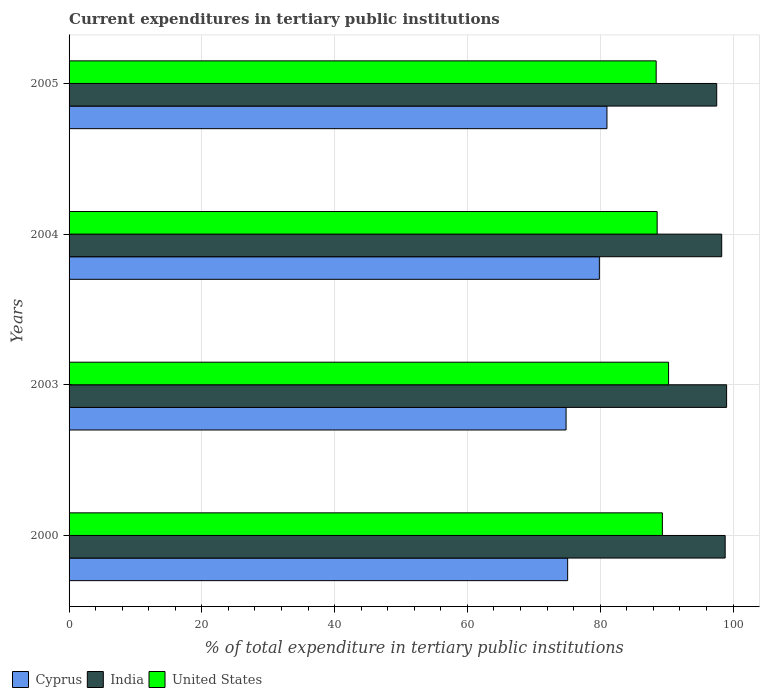How many different coloured bars are there?
Your answer should be very brief. 3. How many groups of bars are there?
Your answer should be very brief. 4. Are the number of bars on each tick of the Y-axis equal?
Offer a very short reply. Yes. How many bars are there on the 2nd tick from the top?
Make the answer very short. 3. What is the current expenditures in tertiary public institutions in Cyprus in 2005?
Keep it short and to the point. 81.01. Across all years, what is the maximum current expenditures in tertiary public institutions in Cyprus?
Provide a short and direct response. 81.01. Across all years, what is the minimum current expenditures in tertiary public institutions in United States?
Offer a terse response. 88.43. In which year was the current expenditures in tertiary public institutions in India maximum?
Offer a very short reply. 2003. What is the total current expenditures in tertiary public institutions in Cyprus in the graph?
Provide a short and direct response. 310.84. What is the difference between the current expenditures in tertiary public institutions in United States in 2000 and that in 2004?
Give a very brief answer. 0.79. What is the difference between the current expenditures in tertiary public institutions in Cyprus in 2005 and the current expenditures in tertiary public institutions in India in 2000?
Your answer should be very brief. -17.81. What is the average current expenditures in tertiary public institutions in India per year?
Your response must be concise. 98.42. In the year 2005, what is the difference between the current expenditures in tertiary public institutions in India and current expenditures in tertiary public institutions in United States?
Your answer should be very brief. 9.12. In how many years, is the current expenditures in tertiary public institutions in India greater than 76 %?
Provide a short and direct response. 4. What is the ratio of the current expenditures in tertiary public institutions in Cyprus in 2000 to that in 2005?
Keep it short and to the point. 0.93. What is the difference between the highest and the second highest current expenditures in tertiary public institutions in India?
Your response must be concise. 0.22. What is the difference between the highest and the lowest current expenditures in tertiary public institutions in India?
Ensure brevity in your answer.  1.49. In how many years, is the current expenditures in tertiary public institutions in Cyprus greater than the average current expenditures in tertiary public institutions in Cyprus taken over all years?
Provide a short and direct response. 2. Is the sum of the current expenditures in tertiary public institutions in United States in 2003 and 2004 greater than the maximum current expenditures in tertiary public institutions in India across all years?
Your response must be concise. Yes. How many bars are there?
Offer a very short reply. 12. Are all the bars in the graph horizontal?
Provide a succinct answer. Yes. What is the difference between two consecutive major ticks on the X-axis?
Offer a terse response. 20. Are the values on the major ticks of X-axis written in scientific E-notation?
Your response must be concise. No. Where does the legend appear in the graph?
Your response must be concise. Bottom left. How are the legend labels stacked?
Ensure brevity in your answer.  Horizontal. What is the title of the graph?
Your answer should be very brief. Current expenditures in tertiary public institutions. What is the label or title of the X-axis?
Provide a succinct answer. % of total expenditure in tertiary public institutions. What is the label or title of the Y-axis?
Give a very brief answer. Years. What is the % of total expenditure in tertiary public institutions of Cyprus in 2000?
Your response must be concise. 75.1. What is the % of total expenditure in tertiary public institutions of India in 2000?
Provide a succinct answer. 98.82. What is the % of total expenditure in tertiary public institutions in United States in 2000?
Offer a terse response. 89.36. What is the % of total expenditure in tertiary public institutions of Cyprus in 2003?
Your response must be concise. 74.86. What is the % of total expenditure in tertiary public institutions of India in 2003?
Provide a succinct answer. 99.04. What is the % of total expenditure in tertiary public institutions of United States in 2003?
Provide a short and direct response. 90.3. What is the % of total expenditure in tertiary public institutions of Cyprus in 2004?
Offer a terse response. 79.87. What is the % of total expenditure in tertiary public institutions in India in 2004?
Your answer should be very brief. 98.3. What is the % of total expenditure in tertiary public institutions of United States in 2004?
Offer a very short reply. 88.57. What is the % of total expenditure in tertiary public institutions in Cyprus in 2005?
Give a very brief answer. 81.01. What is the % of total expenditure in tertiary public institutions of India in 2005?
Provide a succinct answer. 97.55. What is the % of total expenditure in tertiary public institutions of United States in 2005?
Provide a short and direct response. 88.43. Across all years, what is the maximum % of total expenditure in tertiary public institutions of Cyprus?
Offer a terse response. 81.01. Across all years, what is the maximum % of total expenditure in tertiary public institutions in India?
Make the answer very short. 99.04. Across all years, what is the maximum % of total expenditure in tertiary public institutions of United States?
Keep it short and to the point. 90.3. Across all years, what is the minimum % of total expenditure in tertiary public institutions in Cyprus?
Offer a very short reply. 74.86. Across all years, what is the minimum % of total expenditure in tertiary public institutions of India?
Your answer should be compact. 97.55. Across all years, what is the minimum % of total expenditure in tertiary public institutions in United States?
Your answer should be very brief. 88.43. What is the total % of total expenditure in tertiary public institutions of Cyprus in the graph?
Give a very brief answer. 310.84. What is the total % of total expenditure in tertiary public institutions in India in the graph?
Provide a succinct answer. 393.7. What is the total % of total expenditure in tertiary public institutions of United States in the graph?
Keep it short and to the point. 356.66. What is the difference between the % of total expenditure in tertiary public institutions of Cyprus in 2000 and that in 2003?
Provide a short and direct response. 0.24. What is the difference between the % of total expenditure in tertiary public institutions in India in 2000 and that in 2003?
Your response must be concise. -0.22. What is the difference between the % of total expenditure in tertiary public institutions of United States in 2000 and that in 2003?
Give a very brief answer. -0.94. What is the difference between the % of total expenditure in tertiary public institutions of Cyprus in 2000 and that in 2004?
Your response must be concise. -4.78. What is the difference between the % of total expenditure in tertiary public institutions in India in 2000 and that in 2004?
Your answer should be compact. 0.52. What is the difference between the % of total expenditure in tertiary public institutions of United States in 2000 and that in 2004?
Give a very brief answer. 0.79. What is the difference between the % of total expenditure in tertiary public institutions in Cyprus in 2000 and that in 2005?
Your response must be concise. -5.92. What is the difference between the % of total expenditure in tertiary public institutions in India in 2000 and that in 2005?
Offer a very short reply. 1.27. What is the difference between the % of total expenditure in tertiary public institutions in United States in 2000 and that in 2005?
Offer a very short reply. 0.93. What is the difference between the % of total expenditure in tertiary public institutions of Cyprus in 2003 and that in 2004?
Offer a very short reply. -5.01. What is the difference between the % of total expenditure in tertiary public institutions of India in 2003 and that in 2004?
Keep it short and to the point. 0.74. What is the difference between the % of total expenditure in tertiary public institutions in United States in 2003 and that in 2004?
Keep it short and to the point. 1.72. What is the difference between the % of total expenditure in tertiary public institutions in Cyprus in 2003 and that in 2005?
Give a very brief answer. -6.16. What is the difference between the % of total expenditure in tertiary public institutions in India in 2003 and that in 2005?
Give a very brief answer. 1.49. What is the difference between the % of total expenditure in tertiary public institutions in United States in 2003 and that in 2005?
Make the answer very short. 1.87. What is the difference between the % of total expenditure in tertiary public institutions of Cyprus in 2004 and that in 2005?
Your answer should be very brief. -1.14. What is the difference between the % of total expenditure in tertiary public institutions of India in 2004 and that in 2005?
Your answer should be compact. 0.75. What is the difference between the % of total expenditure in tertiary public institutions in United States in 2004 and that in 2005?
Give a very brief answer. 0.15. What is the difference between the % of total expenditure in tertiary public institutions in Cyprus in 2000 and the % of total expenditure in tertiary public institutions in India in 2003?
Provide a short and direct response. -23.94. What is the difference between the % of total expenditure in tertiary public institutions of Cyprus in 2000 and the % of total expenditure in tertiary public institutions of United States in 2003?
Provide a short and direct response. -15.2. What is the difference between the % of total expenditure in tertiary public institutions in India in 2000 and the % of total expenditure in tertiary public institutions in United States in 2003?
Your answer should be very brief. 8.52. What is the difference between the % of total expenditure in tertiary public institutions of Cyprus in 2000 and the % of total expenditure in tertiary public institutions of India in 2004?
Give a very brief answer. -23.2. What is the difference between the % of total expenditure in tertiary public institutions in Cyprus in 2000 and the % of total expenditure in tertiary public institutions in United States in 2004?
Provide a succinct answer. -13.48. What is the difference between the % of total expenditure in tertiary public institutions of India in 2000 and the % of total expenditure in tertiary public institutions of United States in 2004?
Your answer should be very brief. 10.25. What is the difference between the % of total expenditure in tertiary public institutions of Cyprus in 2000 and the % of total expenditure in tertiary public institutions of India in 2005?
Your answer should be very brief. -22.45. What is the difference between the % of total expenditure in tertiary public institutions of Cyprus in 2000 and the % of total expenditure in tertiary public institutions of United States in 2005?
Keep it short and to the point. -13.33. What is the difference between the % of total expenditure in tertiary public institutions in India in 2000 and the % of total expenditure in tertiary public institutions in United States in 2005?
Ensure brevity in your answer.  10.39. What is the difference between the % of total expenditure in tertiary public institutions of Cyprus in 2003 and the % of total expenditure in tertiary public institutions of India in 2004?
Your answer should be compact. -23.44. What is the difference between the % of total expenditure in tertiary public institutions in Cyprus in 2003 and the % of total expenditure in tertiary public institutions in United States in 2004?
Make the answer very short. -13.72. What is the difference between the % of total expenditure in tertiary public institutions of India in 2003 and the % of total expenditure in tertiary public institutions of United States in 2004?
Offer a very short reply. 10.46. What is the difference between the % of total expenditure in tertiary public institutions in Cyprus in 2003 and the % of total expenditure in tertiary public institutions in India in 2005?
Your answer should be very brief. -22.69. What is the difference between the % of total expenditure in tertiary public institutions in Cyprus in 2003 and the % of total expenditure in tertiary public institutions in United States in 2005?
Your answer should be compact. -13.57. What is the difference between the % of total expenditure in tertiary public institutions in India in 2003 and the % of total expenditure in tertiary public institutions in United States in 2005?
Give a very brief answer. 10.61. What is the difference between the % of total expenditure in tertiary public institutions in Cyprus in 2004 and the % of total expenditure in tertiary public institutions in India in 2005?
Keep it short and to the point. -17.67. What is the difference between the % of total expenditure in tertiary public institutions of Cyprus in 2004 and the % of total expenditure in tertiary public institutions of United States in 2005?
Provide a succinct answer. -8.56. What is the difference between the % of total expenditure in tertiary public institutions in India in 2004 and the % of total expenditure in tertiary public institutions in United States in 2005?
Give a very brief answer. 9.87. What is the average % of total expenditure in tertiary public institutions in Cyprus per year?
Offer a terse response. 77.71. What is the average % of total expenditure in tertiary public institutions in India per year?
Provide a short and direct response. 98.42. What is the average % of total expenditure in tertiary public institutions in United States per year?
Your answer should be compact. 89.16. In the year 2000, what is the difference between the % of total expenditure in tertiary public institutions in Cyprus and % of total expenditure in tertiary public institutions in India?
Offer a terse response. -23.72. In the year 2000, what is the difference between the % of total expenditure in tertiary public institutions of Cyprus and % of total expenditure in tertiary public institutions of United States?
Your answer should be very brief. -14.27. In the year 2000, what is the difference between the % of total expenditure in tertiary public institutions in India and % of total expenditure in tertiary public institutions in United States?
Make the answer very short. 9.46. In the year 2003, what is the difference between the % of total expenditure in tertiary public institutions of Cyprus and % of total expenditure in tertiary public institutions of India?
Make the answer very short. -24.18. In the year 2003, what is the difference between the % of total expenditure in tertiary public institutions of Cyprus and % of total expenditure in tertiary public institutions of United States?
Make the answer very short. -15.44. In the year 2003, what is the difference between the % of total expenditure in tertiary public institutions in India and % of total expenditure in tertiary public institutions in United States?
Make the answer very short. 8.74. In the year 2004, what is the difference between the % of total expenditure in tertiary public institutions of Cyprus and % of total expenditure in tertiary public institutions of India?
Offer a very short reply. -18.43. In the year 2004, what is the difference between the % of total expenditure in tertiary public institutions of Cyprus and % of total expenditure in tertiary public institutions of United States?
Offer a very short reply. -8.7. In the year 2004, what is the difference between the % of total expenditure in tertiary public institutions of India and % of total expenditure in tertiary public institutions of United States?
Ensure brevity in your answer.  9.72. In the year 2005, what is the difference between the % of total expenditure in tertiary public institutions in Cyprus and % of total expenditure in tertiary public institutions in India?
Keep it short and to the point. -16.53. In the year 2005, what is the difference between the % of total expenditure in tertiary public institutions in Cyprus and % of total expenditure in tertiary public institutions in United States?
Keep it short and to the point. -7.41. In the year 2005, what is the difference between the % of total expenditure in tertiary public institutions of India and % of total expenditure in tertiary public institutions of United States?
Your answer should be very brief. 9.12. What is the ratio of the % of total expenditure in tertiary public institutions of India in 2000 to that in 2003?
Keep it short and to the point. 1. What is the ratio of the % of total expenditure in tertiary public institutions of Cyprus in 2000 to that in 2004?
Offer a very short reply. 0.94. What is the ratio of the % of total expenditure in tertiary public institutions in India in 2000 to that in 2004?
Make the answer very short. 1.01. What is the ratio of the % of total expenditure in tertiary public institutions of United States in 2000 to that in 2004?
Offer a terse response. 1.01. What is the ratio of the % of total expenditure in tertiary public institutions of Cyprus in 2000 to that in 2005?
Offer a terse response. 0.93. What is the ratio of the % of total expenditure in tertiary public institutions of India in 2000 to that in 2005?
Your answer should be compact. 1.01. What is the ratio of the % of total expenditure in tertiary public institutions in United States in 2000 to that in 2005?
Keep it short and to the point. 1.01. What is the ratio of the % of total expenditure in tertiary public institutions of Cyprus in 2003 to that in 2004?
Provide a succinct answer. 0.94. What is the ratio of the % of total expenditure in tertiary public institutions in India in 2003 to that in 2004?
Give a very brief answer. 1.01. What is the ratio of the % of total expenditure in tertiary public institutions in United States in 2003 to that in 2004?
Ensure brevity in your answer.  1.02. What is the ratio of the % of total expenditure in tertiary public institutions of Cyprus in 2003 to that in 2005?
Offer a terse response. 0.92. What is the ratio of the % of total expenditure in tertiary public institutions in India in 2003 to that in 2005?
Provide a short and direct response. 1.02. What is the ratio of the % of total expenditure in tertiary public institutions in United States in 2003 to that in 2005?
Your response must be concise. 1.02. What is the ratio of the % of total expenditure in tertiary public institutions of Cyprus in 2004 to that in 2005?
Give a very brief answer. 0.99. What is the ratio of the % of total expenditure in tertiary public institutions of India in 2004 to that in 2005?
Ensure brevity in your answer.  1.01. What is the ratio of the % of total expenditure in tertiary public institutions of United States in 2004 to that in 2005?
Your response must be concise. 1. What is the difference between the highest and the second highest % of total expenditure in tertiary public institutions of Cyprus?
Your answer should be compact. 1.14. What is the difference between the highest and the second highest % of total expenditure in tertiary public institutions in India?
Offer a very short reply. 0.22. What is the difference between the highest and the second highest % of total expenditure in tertiary public institutions in United States?
Your response must be concise. 0.94. What is the difference between the highest and the lowest % of total expenditure in tertiary public institutions in Cyprus?
Offer a terse response. 6.16. What is the difference between the highest and the lowest % of total expenditure in tertiary public institutions in India?
Keep it short and to the point. 1.49. What is the difference between the highest and the lowest % of total expenditure in tertiary public institutions in United States?
Provide a succinct answer. 1.87. 